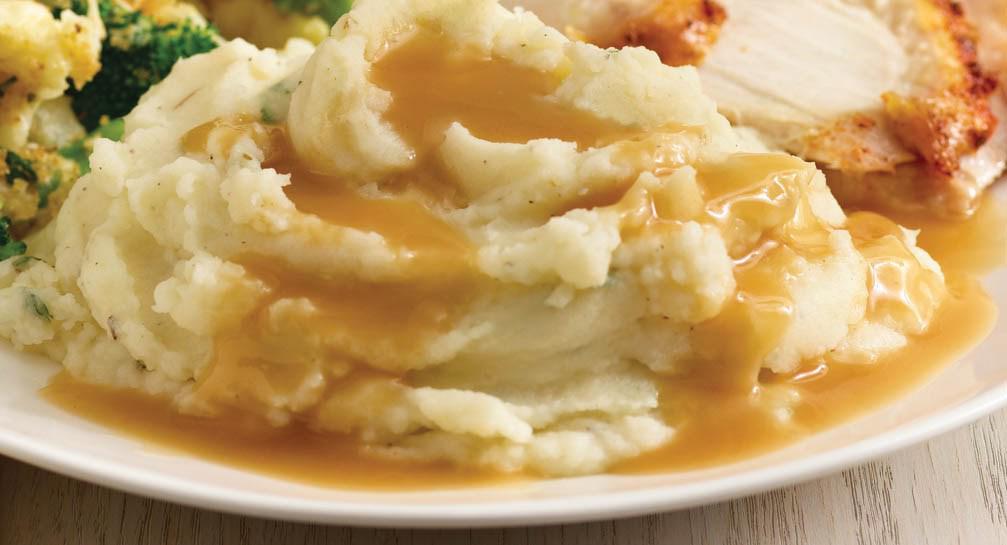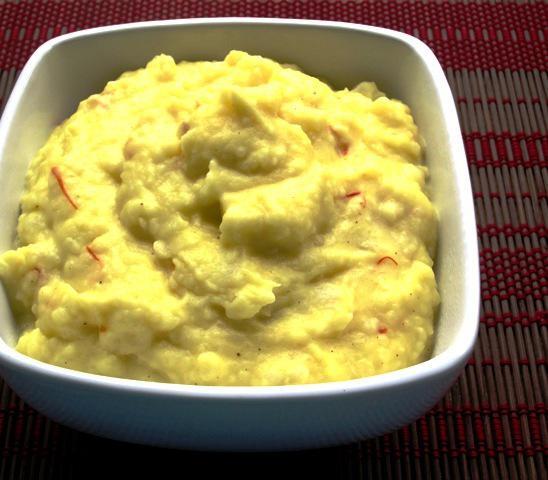The first image is the image on the left, the second image is the image on the right. Considering the images on both sides, is "Each image shows mashed potatoes served - without gravy or other menu items - in a round white bowl." valid? Answer yes or no. No. 